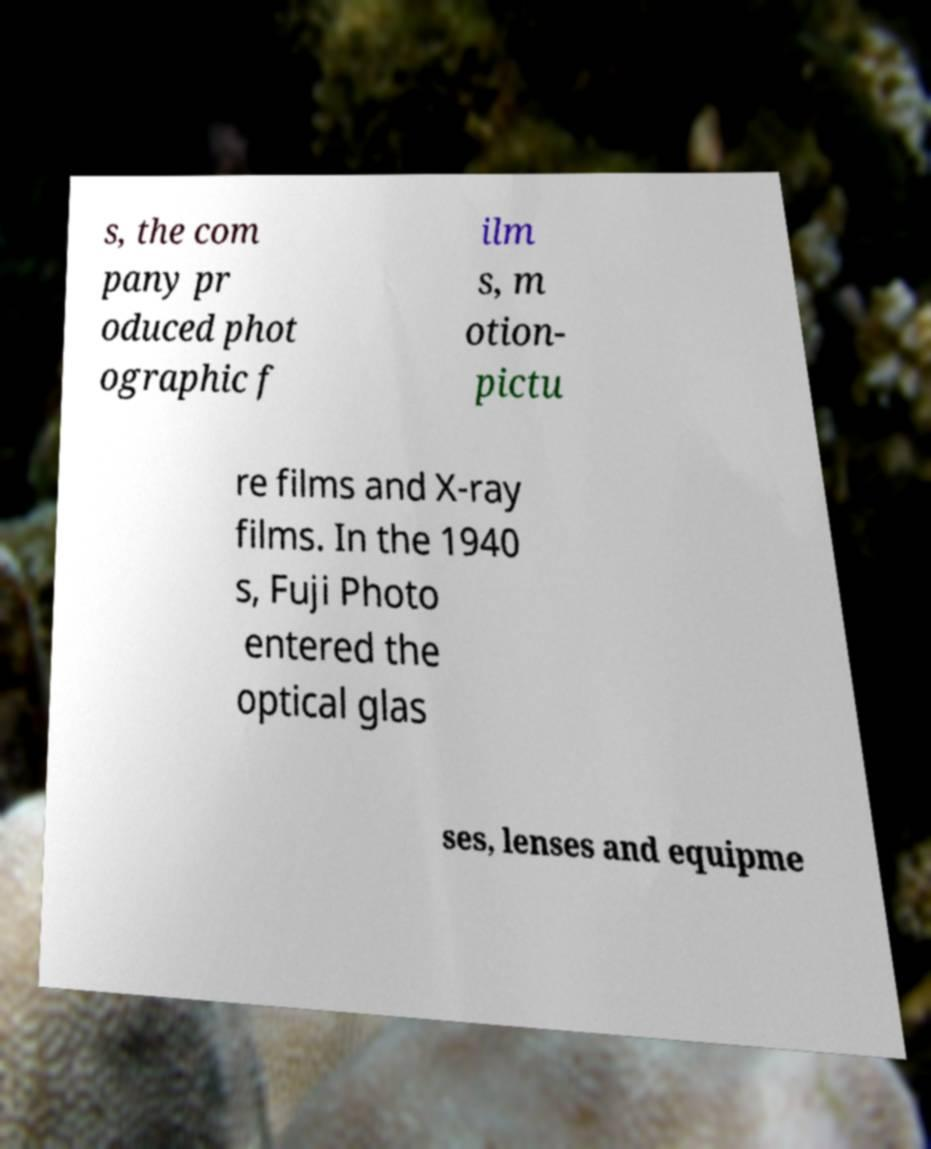Please read and relay the text visible in this image. What does it say? s, the com pany pr oduced phot ographic f ilm s, m otion- pictu re films and X-ray films. In the 1940 s, Fuji Photo entered the optical glas ses, lenses and equipme 